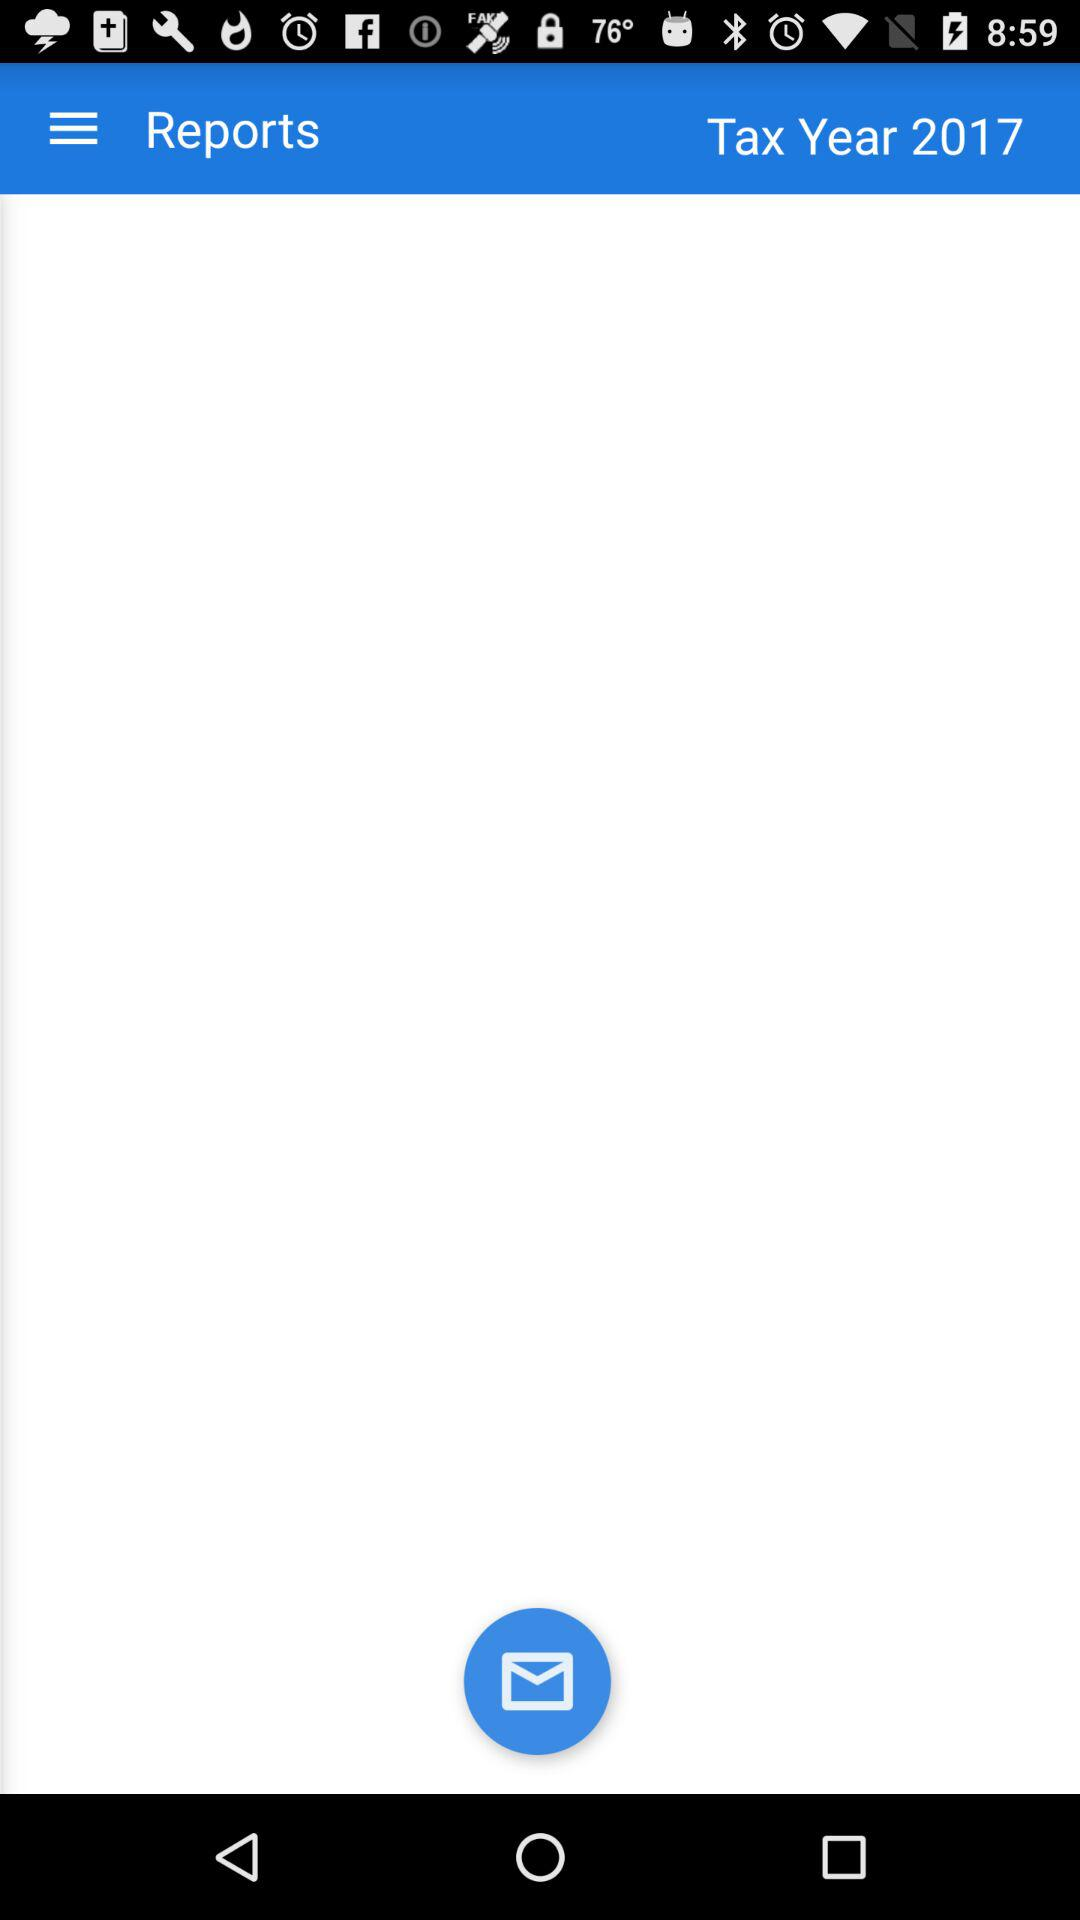What is the given tax year? The given tax year is 2017. 